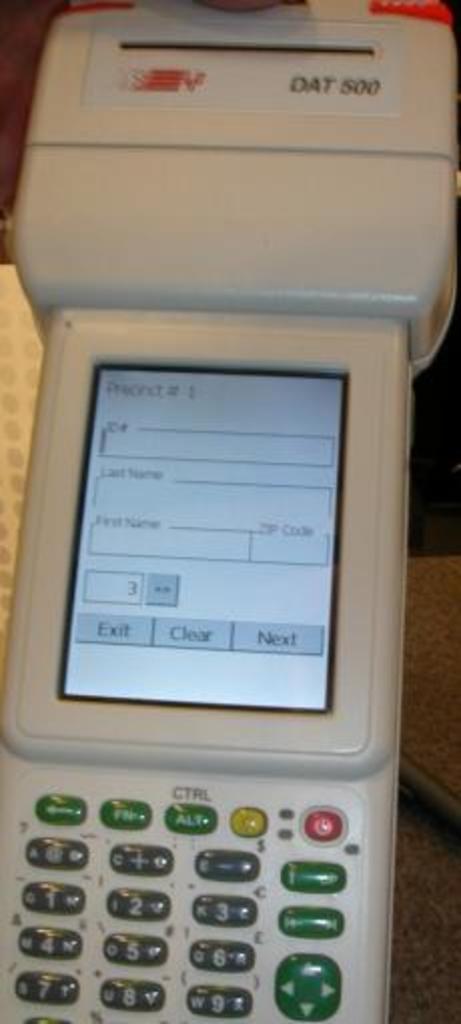What model is this?
Your response must be concise. Dat 500. 